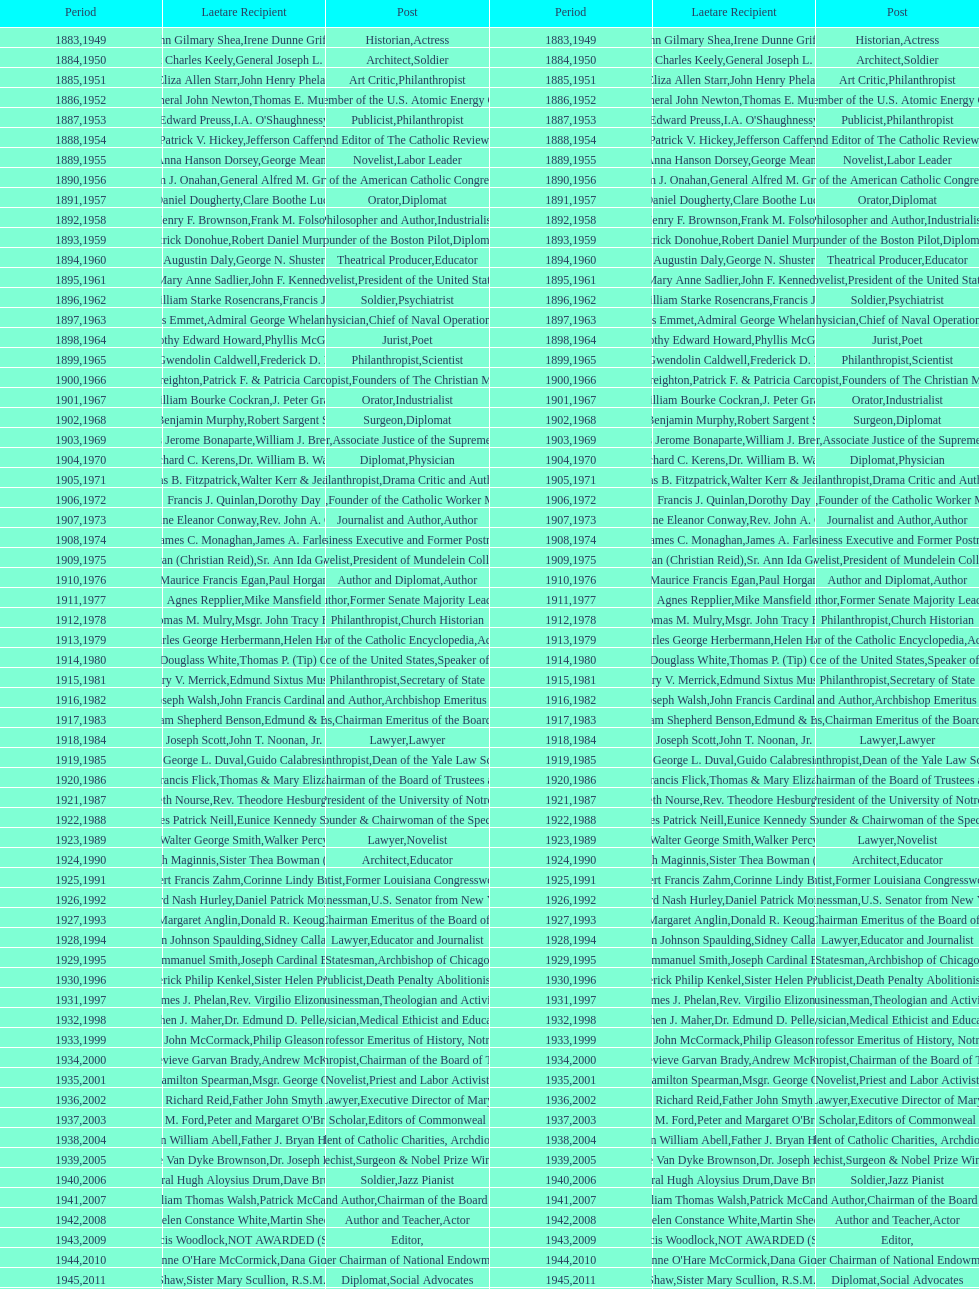Parse the full table. {'header': ['Period', 'Laetare Recipient', 'Post', 'Period', 'Laetare Recipient', 'Post'], 'rows': [['1883', 'John Gilmary Shea', 'Historian', '1949', 'Irene Dunne Griffin', 'Actress'], ['1884', 'Patrick Charles Keely', 'Architect', '1950', 'General Joseph L. Collins', 'Soldier'], ['1885', 'Eliza Allen Starr', 'Art Critic', '1951', 'John Henry Phelan', 'Philanthropist'], ['1886', 'General John Newton', 'Engineer', '1952', 'Thomas E. Murray', 'Member of the U.S. Atomic Energy Commission'], ['1887', 'Edward Preuss', 'Publicist', '1953', "I.A. O'Shaughnessy", 'Philanthropist'], ['1888', 'Patrick V. Hickey', 'Founder and Editor of The Catholic Review', '1954', 'Jefferson Caffery', 'Diplomat'], ['1889', 'Anna Hanson Dorsey', 'Novelist', '1955', 'George Meany', 'Labor Leader'], ['1890', 'William J. Onahan', 'Organizer of the American Catholic Congress', '1956', 'General Alfred M. Gruenther', 'Soldier'], ['1891', 'Daniel Dougherty', 'Orator', '1957', 'Clare Boothe Luce', 'Diplomat'], ['1892', 'Henry F. Brownson', 'Philosopher and Author', '1958', 'Frank M. Folsom', 'Industrialist'], ['1893', 'Patrick Donohue', 'Founder of the Boston Pilot', '1959', 'Robert Daniel Murphy', 'Diplomat'], ['1894', 'Augustin Daly', 'Theatrical Producer', '1960', 'George N. Shuster', 'Educator'], ['1895', 'Mary Anne Sadlier', 'Novelist', '1961', 'John F. Kennedy', 'President of the United States'], ['1896', 'General William Starke Rosencrans', 'Soldier', '1962', 'Francis J. Braceland', 'Psychiatrist'], ['1897', 'Thomas Addis Emmet', 'Physician', '1963', 'Admiral George Whelan Anderson, Jr.', 'Chief of Naval Operations'], ['1898', 'Timothy Edward Howard', 'Jurist', '1964', 'Phyllis McGinley', 'Poet'], ['1899', 'Mary Gwendolin Caldwell', 'Philanthropist', '1965', 'Frederick D. Rossini', 'Scientist'], ['1900', 'John A. Creighton', 'Philanthropist', '1966', 'Patrick F. & Patricia Caron Crowley', 'Founders of The Christian Movement'], ['1901', 'William Bourke Cockran', 'Orator', '1967', 'J. Peter Grace', 'Industrialist'], ['1902', 'John Benjamin Murphy', 'Surgeon', '1968', 'Robert Sargent Shriver', 'Diplomat'], ['1903', 'Charles Jerome Bonaparte', 'Lawyer', '1969', 'William J. Brennan Jr.', 'Associate Justice of the Supreme Court'], ['1904', 'Richard C. Kerens', 'Diplomat', '1970', 'Dr. William B. Walsh', 'Physician'], ['1905', 'Thomas B. Fitzpatrick', 'Philanthropist', '1971', 'Walter Kerr & Jean Kerr', 'Drama Critic and Author'], ['1906', 'Francis J. Quinlan', 'Physician', '1972', 'Dorothy Day', 'Founder of the Catholic Worker Movement'], ['1907', 'Katherine Eleanor Conway', 'Journalist and Author', '1973', "Rev. John A. O'Brien", 'Author'], ['1908', 'James C. Monaghan', 'Economist', '1974', 'James A. Farley', 'Business Executive and Former Postmaster General'], ['1909', 'Frances Tieran (Christian Reid)', 'Novelist', '1975', 'Sr. Ann Ida Gannon, BMV', 'President of Mundelein College'], ['1910', 'Maurice Francis Egan', 'Author and Diplomat', '1976', 'Paul Horgan', 'Author'], ['1911', 'Agnes Repplier', 'Author', '1977', 'Mike Mansfield', 'Former Senate Majority Leader'], ['1912', 'Thomas M. Mulry', 'Philanthropist', '1978', 'Msgr. John Tracy Ellis', 'Church Historian'], ['1913', 'Charles George Herbermann', 'Editor of the Catholic Encyclopedia', '1979', 'Helen Hayes', 'Actress'], ['1914', 'Edward Douglass White', 'Chief Justice of the United States', '1980', "Thomas P. (Tip) O'Neill Jr.", 'Speaker of the House'], ['1915', 'Mary V. Merrick', 'Philanthropist', '1981', 'Edmund Sixtus Muskie', 'Secretary of State'], ['1916', 'James Joseph Walsh', 'Physician and Author', '1982', 'John Francis Cardinal Dearden', 'Archbishop Emeritus of Detroit'], ['1917', 'Admiral William Shepherd Benson', 'Chief of Naval Operations', '1983', 'Edmund & Evelyn Stephan', 'Chairman Emeritus of the Board of Trustees and his wife'], ['1918', 'Joseph Scott', 'Lawyer', '1984', 'John T. Noonan, Jr.', 'Lawyer'], ['1919', 'George L. Duval', 'Philanthropist', '1985', 'Guido Calabresi', 'Dean of the Yale Law School'], ['1920', 'Lawrence Francis Flick', 'Physician', '1986', 'Thomas & Mary Elizabeth Carney', 'Chairman of the Board of Trustees and his wife'], ['1921', 'Elizabeth Nourse', 'Artist', '1987', 'Rev. Theodore Hesburgh, CSC', 'President of the University of Notre Dame'], ['1922', 'Charles Patrick Neill', 'Economist', '1988', 'Eunice Kennedy Shriver', 'Founder & Chairwoman of the Special Olympics'], ['1923', 'Walter George Smith', 'Lawyer', '1989', 'Walker Percy', 'Novelist'], ['1924', 'Charles Donagh Maginnis', 'Architect', '1990', 'Sister Thea Bowman (posthumously)', 'Educator'], ['1925', 'Albert Francis Zahm', 'Scientist', '1991', 'Corinne Lindy Boggs', 'Former Louisiana Congresswoman'], ['1926', 'Edward Nash Hurley', 'Businessman', '1992', 'Daniel Patrick Moynihan', 'U.S. Senator from New York'], ['1927', 'Margaret Anglin', 'Actress', '1993', 'Donald R. Keough', 'Chairman Emeritus of the Board of Trustees'], ['1928', 'John Johnson Spaulding', 'Lawyer', '1994', 'Sidney Callahan', 'Educator and Journalist'], ['1929', 'Alfred Emmanuel Smith', 'Statesman', '1995', 'Joseph Cardinal Bernardin', 'Archbishop of Chicago'], ['1930', 'Frederick Philip Kenkel', 'Publicist', '1996', 'Sister Helen Prejean', 'Death Penalty Abolitionist'], ['1931', 'James J. Phelan', 'Businessman', '1997', 'Rev. Virgilio Elizondo', 'Theologian and Activist'], ['1932', 'Stephen J. Maher', 'Physician', '1998', 'Dr. Edmund D. Pellegrino', 'Medical Ethicist and Educator'], ['1933', 'John McCormack', 'Artist', '1999', 'Philip Gleason', 'Professor Emeritus of History, Notre Dame'], ['1934', 'Genevieve Garvan Brady', 'Philanthropist', '2000', 'Andrew McKenna', 'Chairman of the Board of Trustees'], ['1935', 'Francis Hamilton Spearman', 'Novelist', '2001', 'Msgr. George G. Higgins', 'Priest and Labor Activist'], ['1936', 'Richard Reid', 'Journalist and Lawyer', '2002', 'Father John Smyth', 'Executive Director of Maryville Academy'], ['1937', 'Jeremiah D. M. Ford', 'Scholar', '2003', "Peter and Margaret O'Brien Steinfels", 'Editors of Commonweal'], ['1938', 'Irvin William Abell', 'Surgeon', '2004', 'Father J. Bryan Hehir', 'President of Catholic Charities, Archdiocese of Boston'], ['1939', 'Josephine Van Dyke Brownson', 'Catechist', '2005', 'Dr. Joseph E. Murray', 'Surgeon & Nobel Prize Winner'], ['1940', 'General Hugh Aloysius Drum', 'Soldier', '2006', 'Dave Brubeck', 'Jazz Pianist'], ['1941', 'William Thomas Walsh', 'Journalist and Author', '2007', 'Patrick McCartan', 'Chairman of the Board of Trustees'], ['1942', 'Helen Constance White', 'Author and Teacher', '2008', 'Martin Sheen', 'Actor'], ['1943', 'Thomas Francis Woodlock', 'Editor', '2009', 'NOT AWARDED (SEE BELOW)', ''], ['1944', "Anne O'Hare McCormick", 'Journalist', '2010', 'Dana Gioia', 'Former Chairman of National Endowment for the Arts'], ['1945', 'Gardiner Howland Shaw', 'Diplomat', '2011', 'Sister Mary Scullion, R.S.M., & Joan McConnon', 'Social Advocates'], ['1946', 'Carlton J. H. Hayes', 'Historian and Diplomat', '2012', 'Ken Hackett', 'Former President of Catholic Relief Services'], ['1947', 'William G. Bruce', 'Publisher and Civic Leader', '2013', 'Sister Susanne Gallagher, S.P.\\nSister Mary Therese Harrington, S.H.\\nRev. James H. McCarthy', 'Founders of S.P.R.E.D. (Special Religious Education Development Network)'], ['1948', 'Frank C. Walker', 'Postmaster General and Civic Leader', '2014', 'Kenneth R. Miller', 'Professor of Biology at Brown University']]} How many laetare medalists were philantrohpists? 2. 